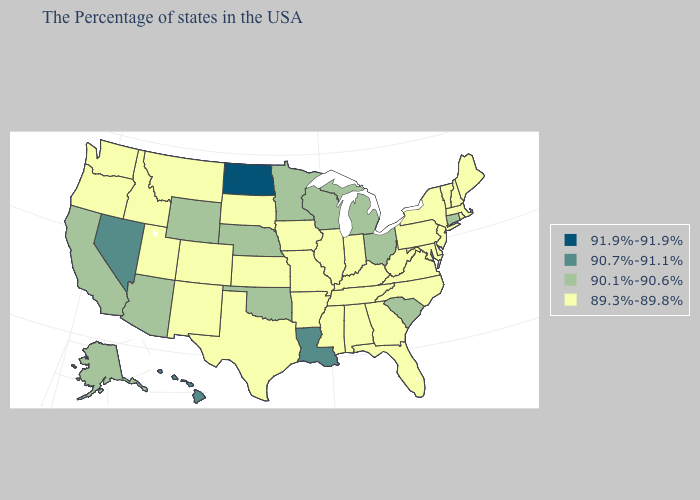How many symbols are there in the legend?
Keep it brief. 4. What is the highest value in the USA?
Quick response, please. 91.9%-91.9%. Name the states that have a value in the range 91.9%-91.9%?
Quick response, please. North Dakota. Does the first symbol in the legend represent the smallest category?
Answer briefly. No. Does Washington have the lowest value in the West?
Keep it brief. Yes. What is the value of New Hampshire?
Keep it brief. 89.3%-89.8%. What is the value of Florida?
Answer briefly. 89.3%-89.8%. Does the first symbol in the legend represent the smallest category?
Write a very short answer. No. What is the value of Colorado?
Give a very brief answer. 89.3%-89.8%. What is the lowest value in the USA?
Keep it brief. 89.3%-89.8%. Does Vermont have the lowest value in the Northeast?
Be succinct. Yes. What is the lowest value in states that border Iowa?
Give a very brief answer. 89.3%-89.8%. Does Georgia have a lower value than Utah?
Short answer required. No. Name the states that have a value in the range 91.9%-91.9%?
Quick response, please. North Dakota. 